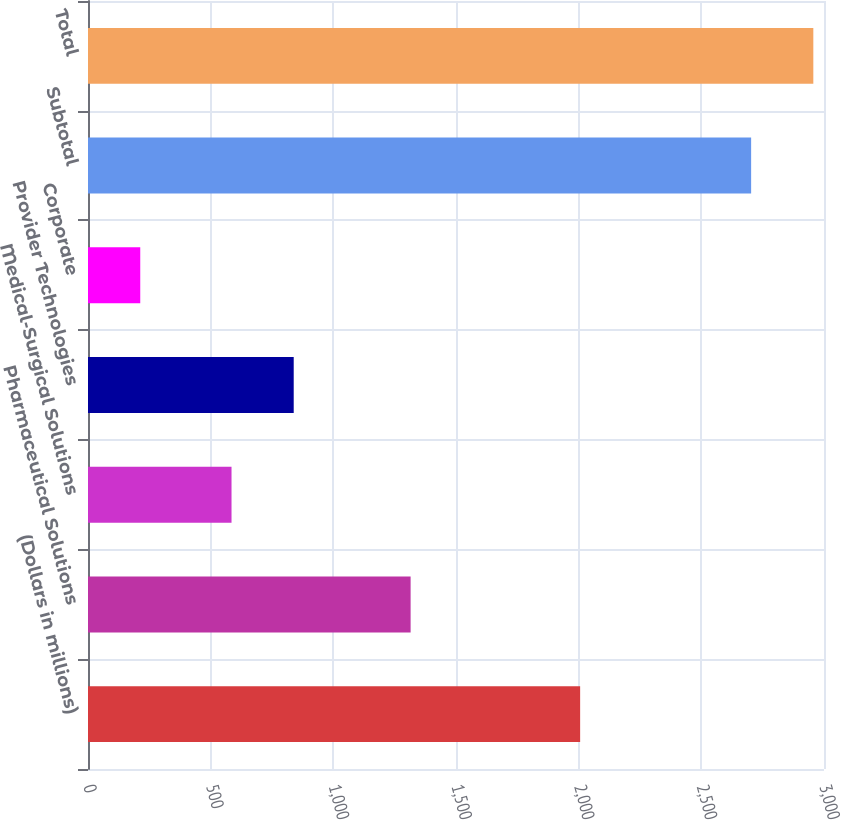Convert chart. <chart><loc_0><loc_0><loc_500><loc_500><bar_chart><fcel>(Dollars in millions)<fcel>Pharmaceutical Solutions<fcel>Medical-Surgical Solutions<fcel>Provider Technologies<fcel>Corporate<fcel>Subtotal<fcel>Total<nl><fcel>2006<fcel>1315<fcel>585<fcel>838.5<fcel>213<fcel>2703<fcel>2956.5<nl></chart> 